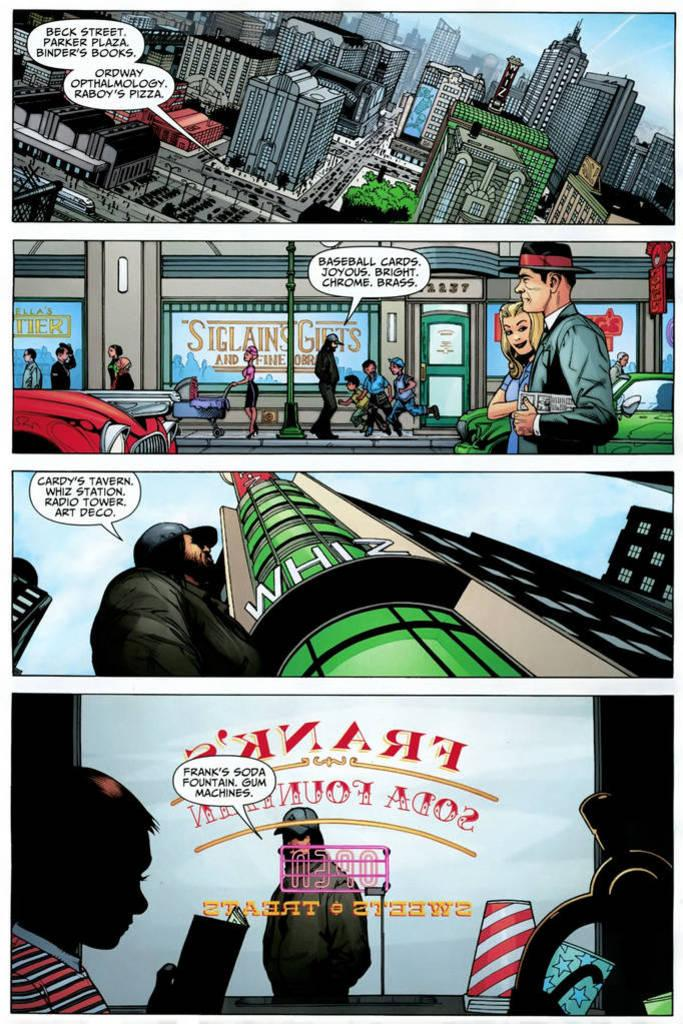What type of image is being described? The image is an animation of a photo collage. What can be seen at the top of the image? There are buildings at the top of the image. What type of chain can be seen connecting the buildings in the image? There is no chain connecting the buildings in the image; it is an animation of a photo collage with buildings at the top. 